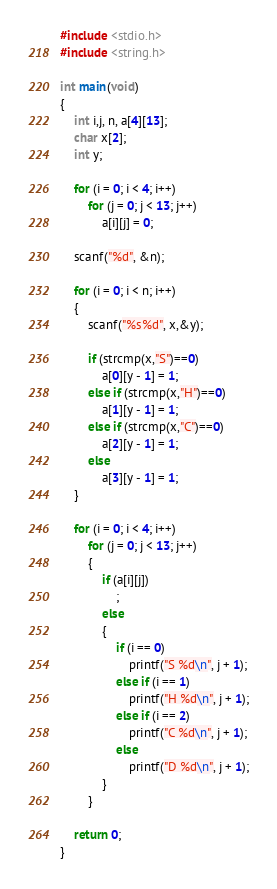<code> <loc_0><loc_0><loc_500><loc_500><_C_>#include <stdio.h>
#include <string.h>

int main(void)
{
	int i,j, n, a[4][13];
	char x[2];
	int y;

	for (i = 0; i < 4; i++)
		for (j = 0; j < 13; j++)
			a[i][j] = 0;

	scanf("%d", &n);

	for (i = 0; i < n; i++)
	{
		scanf("%s%d", x,&y);

		if (strcmp(x,"S")==0)
			a[0][y - 1] = 1;
		else if (strcmp(x,"H")==0)
			a[1][y - 1] = 1;
		else if (strcmp(x,"C")==0)
			a[2][y - 1] = 1;
		else
			a[3][y - 1] = 1;
	}

	for (i = 0; i < 4; i++)
		for (j = 0; j < 13; j++)
		{
			if (a[i][j])
				;
			else
			{
				if (i == 0)
					printf("S %d\n", j + 1);
				else if (i == 1)
					printf("H %d\n", j + 1);
				else if (i == 2)
					printf("C %d\n", j + 1);
				else
					printf("D %d\n", j + 1);
			}
		}
	
	return 0;
}</code> 